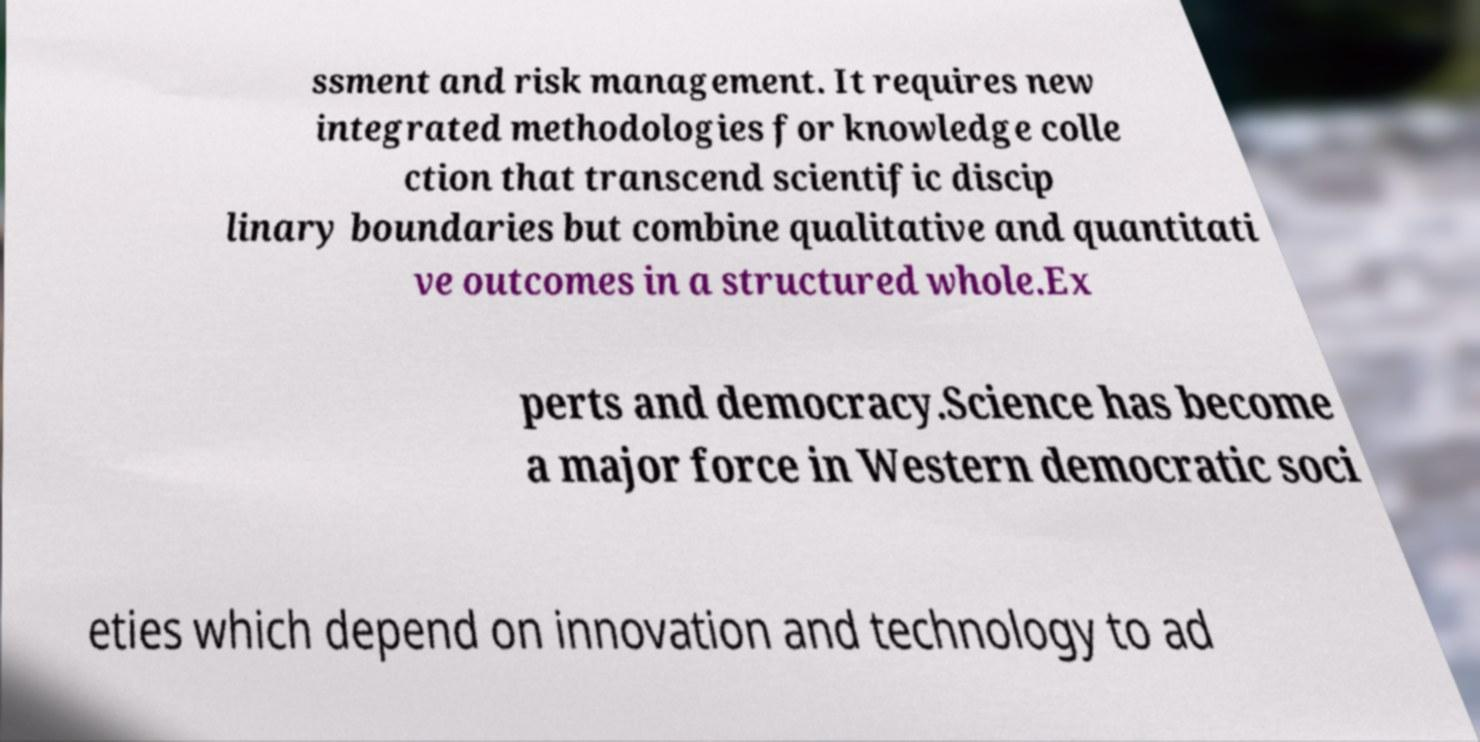Can you read and provide the text displayed in the image?This photo seems to have some interesting text. Can you extract and type it out for me? ssment and risk management. It requires new integrated methodologies for knowledge colle ction that transcend scientific discip linary boundaries but combine qualitative and quantitati ve outcomes in a structured whole.Ex perts and democracy.Science has become a major force in Western democratic soci eties which depend on innovation and technology to ad 